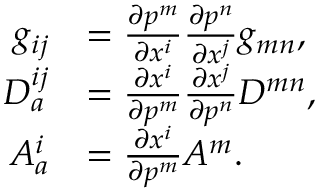<formula> <loc_0><loc_0><loc_500><loc_500>\begin{array} { r l } { g _ { i j } } & { = \frac { \partial p ^ { m } } { \partial x ^ { i } } \frac { \partial p ^ { n } } { \partial x ^ { j } } g _ { m n } , } \\ { D _ { a } ^ { i j } } & { = \frac { \partial x ^ { i } } { \partial p ^ { m } } \frac { \partial x ^ { j } } { \partial p ^ { n } } D ^ { m n } , } \\ { A _ { a } ^ { i } } & { = \frac { \partial x ^ { i } } { \partial p ^ { m } } A ^ { m } . } \end{array}</formula> 